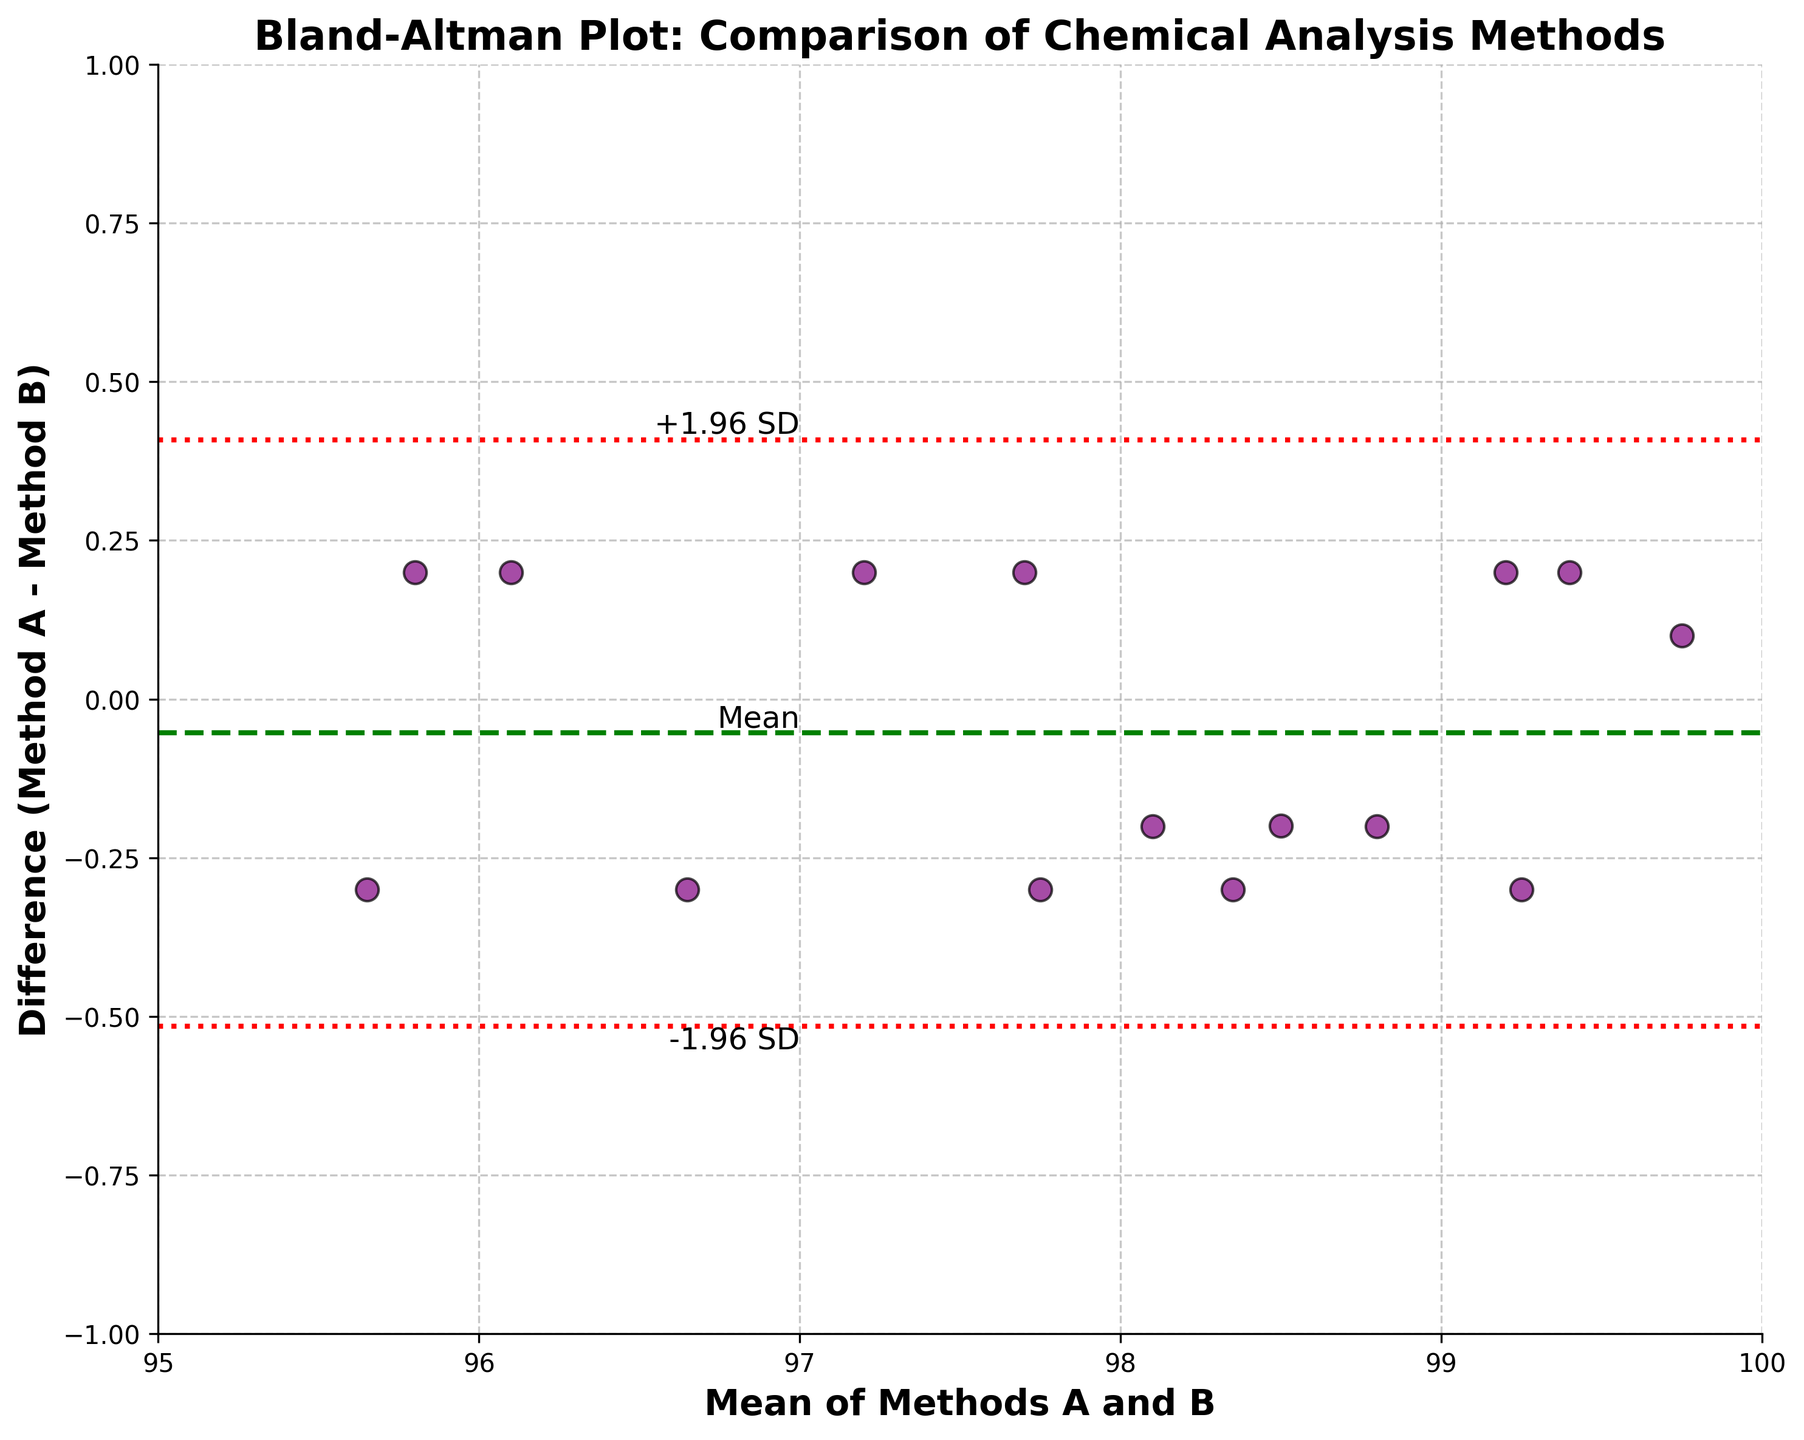What's the title of the figure? The title of the figure is located at the top and it reads 'Bland-Altman Plot: Comparison of Chemical Analysis Methods'
Answer: Bland-Altman Plot: Comparison of Chemical Analysis Methods What are the labels of the x-axis and y-axis? The x-axis label is 'Mean of Methods A and B', and the y-axis label is 'Difference (Method A - Method B)'. These labels are shown below the respective axes.
Answer: Mean of Methods A and B, Difference (Method A - Method B) How many data points are plotted in the scatter plot? By counting the number of data points (purple dots) in the scatter plot, there are 15 points plotted.
Answer: 15 What is the mean difference between Method A and Method B? The mean difference is shown by the green dashed line labeled 'Mean' on the y-axis.
Answer: Mean difference is around 0.03 What is the range of the limits of agreement? The limits of agreement are indicated by the red dotted lines labeled '-1.96 SD' and '+1.96 SD'. The range is from approximately -0.13 to 0.19.
Answer: -0.13 to 0.19 Which agreement limit is closest to the mean difference? Comparing the distances of the σ limits from the mean difference (green dashed line), the +1.96 SD (around 0.19) is closer to the mean difference than -1.96 SD (around -0.13).
Answer: +1.96 SD What is the approximate width of the limits of agreement? The width of the limits of agreement is the difference between the upper limit (+1.96 SD) and the lower limit (-1.96 SD). This is roughly 0.19 - (-0.13) = 0.32 units.
Answer: 0.32 units Are the data points evenly distributed above and below the mean difference? Observing the scatter plot, the purple dots seem relatively evenly distributed both above and below the green dashed line representing the mean difference.
Answer: Yes What does the clustering of data points around the mean of roughly 98 indicate? This clustering suggests that for products with a mean purity around 98, both methods A and B yield similar results with minimal variation.
Answer: Minimal variation around 98 